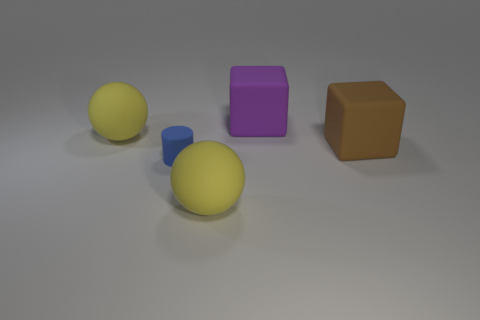There is a ball that is in front of the brown block; what size is it?
Provide a succinct answer. Large. Does the blue cylinder have the same size as the yellow object that is right of the tiny rubber cylinder?
Keep it short and to the point. No. Is the number of large yellow rubber spheres that are on the right side of the matte cylinder less than the number of large yellow rubber balls?
Make the answer very short. Yes. What material is the other big object that is the same shape as the purple thing?
Offer a very short reply. Rubber. There is a big rubber object that is both behind the brown object and to the right of the small rubber cylinder; what is its shape?
Provide a short and direct response. Cube. What is the shape of the purple object that is the same material as the brown cube?
Offer a terse response. Cube. What material is the purple block right of the cylinder?
Offer a terse response. Rubber. Does the purple cube on the right side of the tiny rubber thing have the same size as the yellow object that is behind the big brown matte thing?
Make the answer very short. Yes. What color is the tiny cylinder?
Your answer should be compact. Blue. Is the shape of the large object that is right of the big purple rubber block the same as  the purple object?
Provide a short and direct response. Yes. 